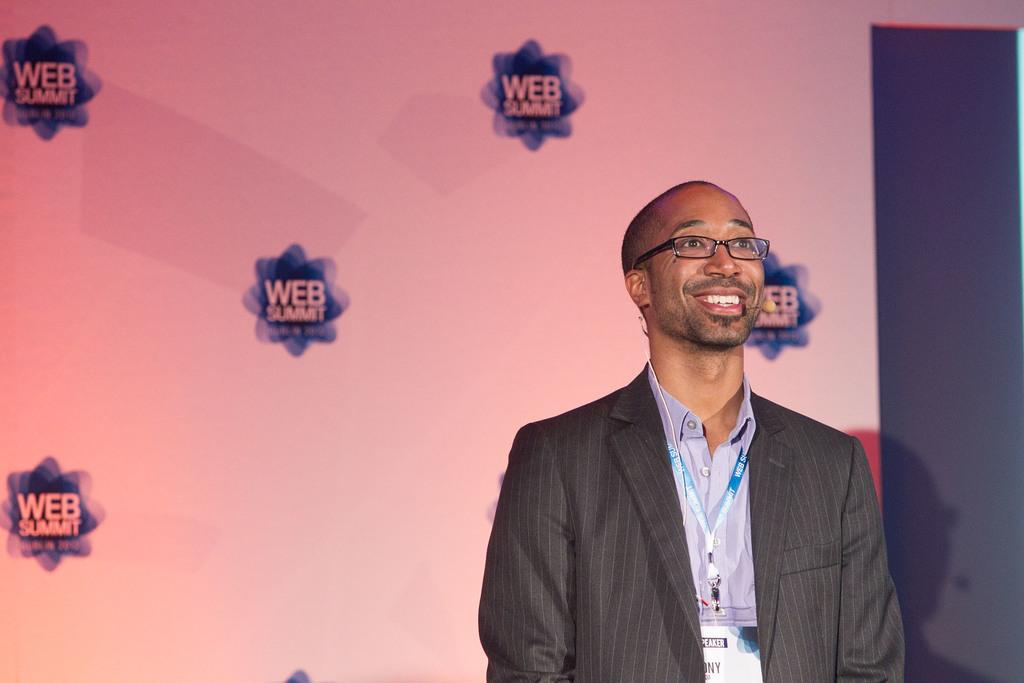Who or what is the main subject in the center of the image? There is a person in the center of the image. What can be seen in the background of the image? There is an advertisement in the background of the image. How many snakes are slithering around the person in the image? There are no snakes present in the image; it features a person and an advertisement in the background. What shape is the person in the image? The shape of the person cannot be determined from the image alone, as it is a two-dimensional representation. 